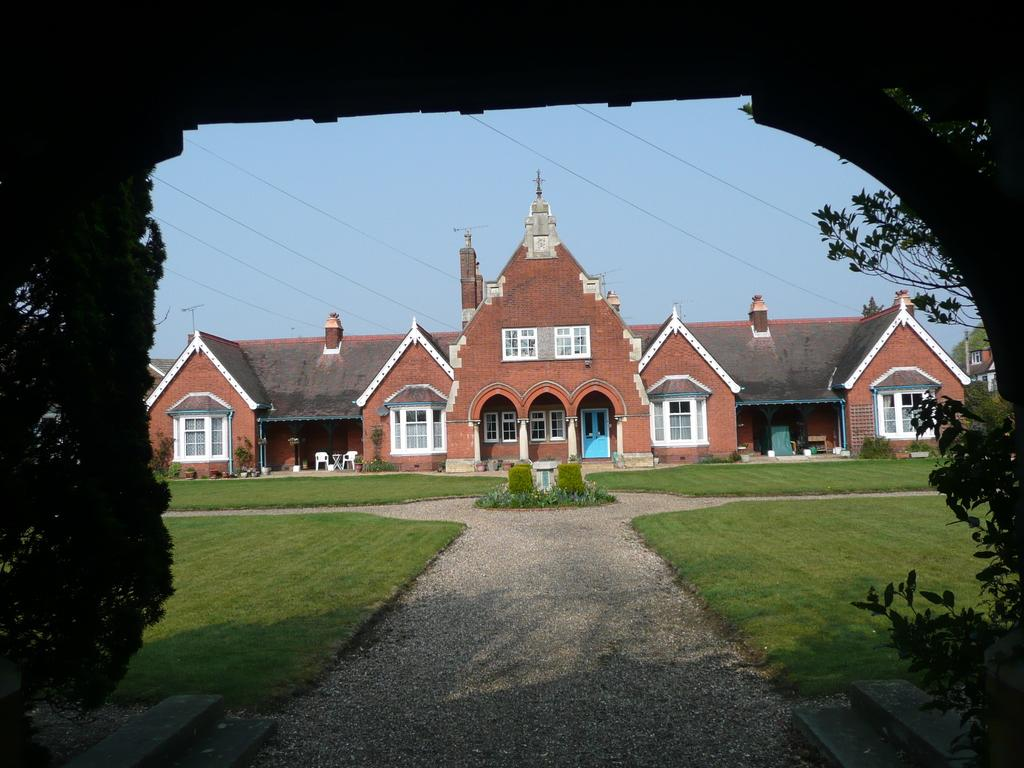What type of structure can be seen in the image? There is an arch in the image. What type of vegetation is present in the image? There are trees in the image. What type of buildings are visible in the image? There are buildings with windows in the image. What type of furniture is present in the image? There are chairs in the image. What type of ground cover is present in the image? There is grass in the image. What can be seen in the background of the image? The sky is visible in the background of the image. How many blades are attached to the guitar in the image? There is no guitar present in the image, and therefore no blades can be associated with it. How many legs are visible on the chairs in the image? The image does not show the legs of the chairs, only the seats are visible. 